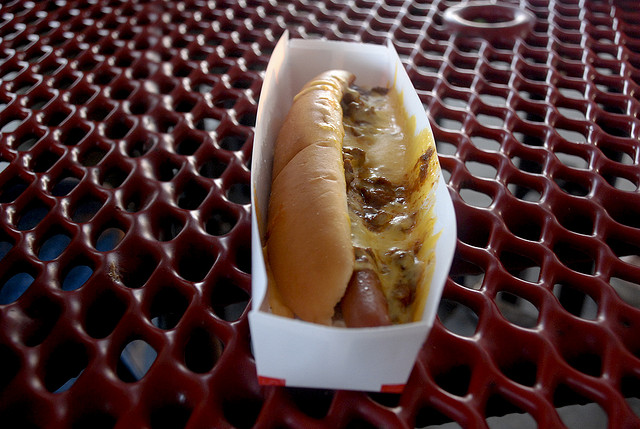What toppings can be seen on the hot dog? The hot dog appears to be topped with what looks like a form of melted cheese, enriching its flavor profile. 